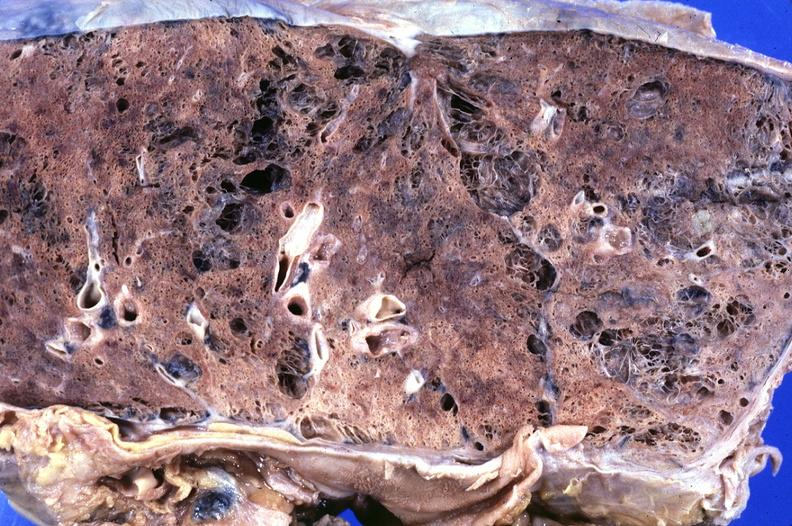does vasculature show lung, emphysema?
Answer the question using a single word or phrase. No 